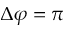Convert formula to latex. <formula><loc_0><loc_0><loc_500><loc_500>\Delta \varphi = \pi</formula> 